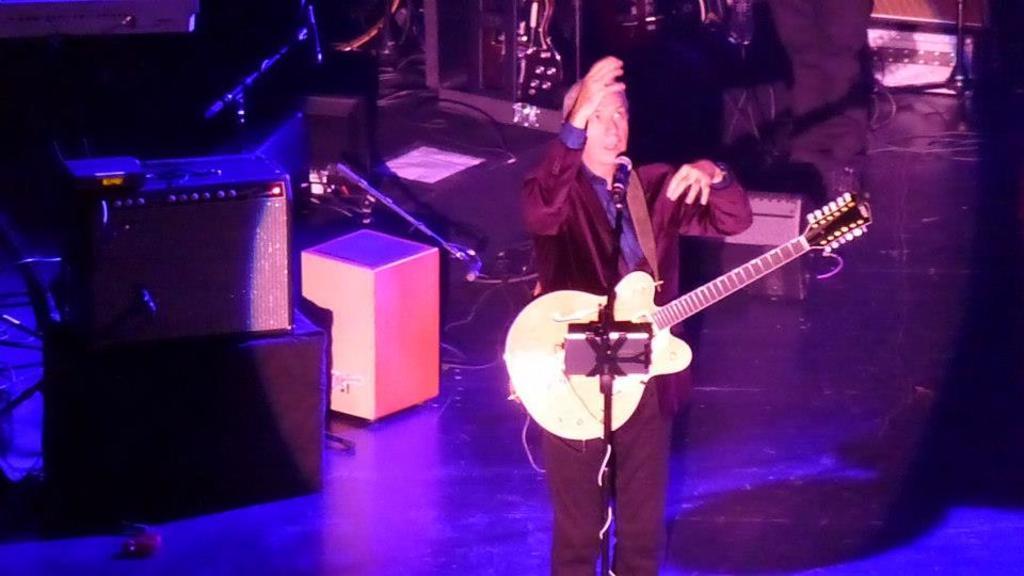Can you describe this image briefly? In this image there is a man standing with a guitar near the micro phone and the background there are speakers and some cables. 